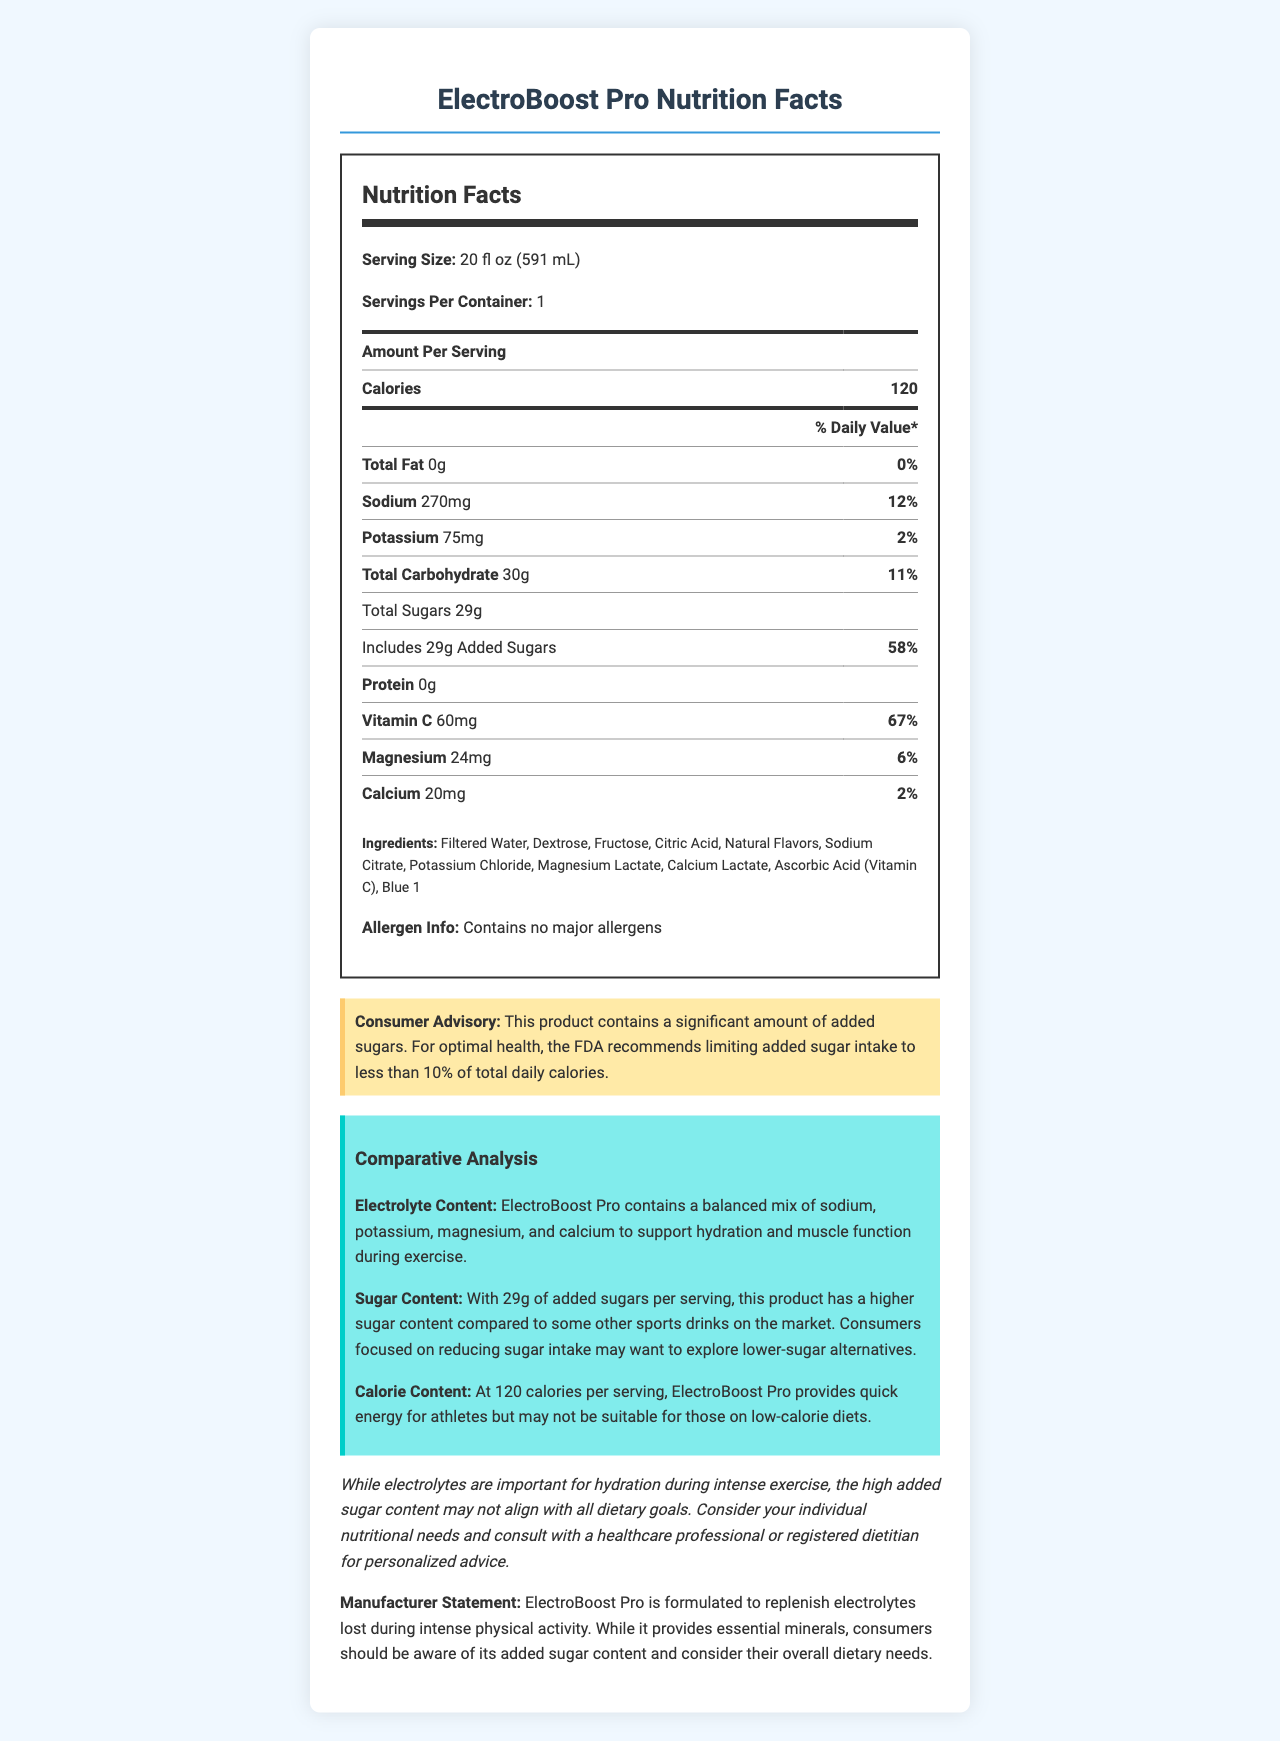what is the calories content for ElectroBoost Pro? The document states that each serving of ElectroBoost Pro contains 120 calories.
Answer: 120 how much sodium is in a serving of ElectroBoost Pro, and what is its percent daily value? The nutrition label shows that one serving of ElectroBoost Pro contains 270mg of sodium, which is 12% of the daily value.
Answer: 270mg, 12% how much added sugars does ElectroBoost Pro contain? The document lists that includes 29g of added sugars.
Answer: 29g what are the main electrolytes included in ElectroBoost Pro? The document states that the electrolytes included are Sodium (270mg), Potassium (75mg), Magnesium (24mg), and Calcium (20mg).
Answer: Sodium, Potassium, Magnesium, Calcium what is the serving size for ElectroBoost Pro? The document specifies that the serving size is 20 fl oz (591 mL).
Answer: 20 fl oz (591 mL) which vitamin is prominently featured in ElectroBoost Pro, and how much is present in each serving? The document notes that each serving includes 60mg of Vitamin C, which is 67% of the daily value.
Answer: Vitamin C, 60mg how does ElectroBoost Pro compare to other sports drinks in terms of sugar content? A. Lower B. Higher C. About the same The document mentions in the comparative analysis that ElectroBoost Pro has a higher sugar content compared to some other sports drinks on the market.
Answer: B. Higher which of the following ingredients is NOT listed in the ElectroBoost Pro? A. Dextrose B. Fructose C. Stevia D. Sodium Citrate The ingredient list includes Dextrose, Fructose, and Sodium Citrate but does not include Stevia.
Answer: C. Stevia is there any major allergen in ElectroBoost Pro? The document states that it contains no major allergens.
Answer: No can ElectroBoost Pro be considered a low-calorie product? At 120 calories per serving, it provides quick energy but may not be suitable for those on low-calorie diets.
Answer: No what is the overall purpose of ElectroBoost Pro according to the manufacturer? The manufacturer states that ElectroBoost Pro is formulated to replenish electrolytes lost during intense physical activity and provides essential minerals.
Answer: To replenish electrolytes lost during intense physical activity what is a key health consideration regarding the high added sugar content in ElectroBoost Pro? The document notes that while electrolytes are important, the high added sugar content may not align with all dietary goals.
Answer: It may not align with all dietary goals what is the consumer advisory about sugar content? The advisory states that for optimal health, the FDA recommends limiting added sugar intake to less than 10% of total daily calories.
Answer: The FDA recommends limiting added sugar intake to less than 10% of total daily calories what is the main idea of the document? The document provides detailed nutrition facts, ingredient list, allergen information, consumer advisory, manufacturer statement, and a comparative analysis regarding ElectroBoost Pro's electrolyte, sugar, and calorie content.
Answer: ElectroBoost Pro is a sports drink designed to replenish electrolytes and provide quick energy, but it contains a high amount of added sugars, which may not fit all dietary needs. how much protein is in ElectroBoost Pro? The nutrition label indicates that there is no protein in ElectroBoost Pro.
Answer: 0g what is the daily value percentage of potassium in ElectroBoost Pro? The document lists the percent daily value of potassium as 2%.
Answer: 2% what is the main sweetening ingredient in ElectroBoost Pro? The document lists Dextrose and Fructose as ingredients, but it does not specify which one is the primary sweetener.
Answer: Cannot be determined 